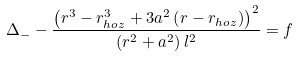<formula> <loc_0><loc_0><loc_500><loc_500>\Delta _ { - } - \frac { \left ( r ^ { 3 } - r _ { h o z } ^ { 3 } + 3 a ^ { 2 } \left ( r - r _ { h o z } \right ) \right ) ^ { 2 } } { \left ( r ^ { 2 } + a ^ { 2 } \right ) l ^ { 2 } } = f</formula> 